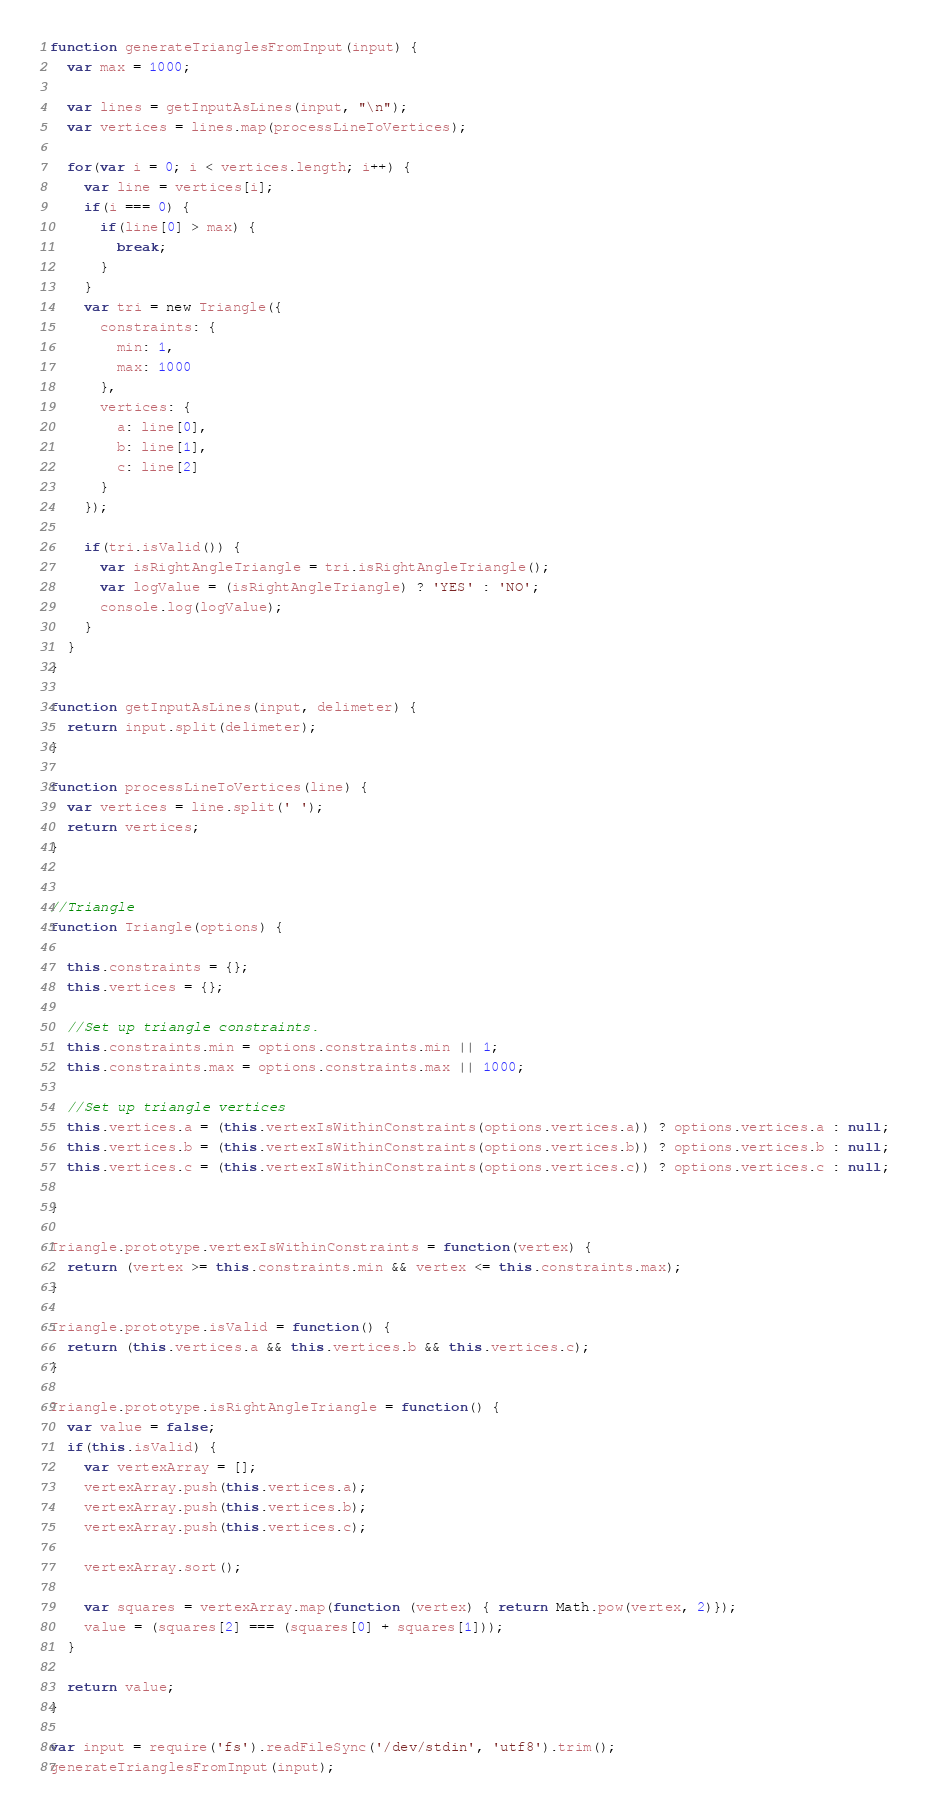Convert code to text. <code><loc_0><loc_0><loc_500><loc_500><_JavaScript_>function generateTrianglesFromInput(input) {
  var max = 1000;

  var lines = getInputAsLines(input, "\n");
  var vertices = lines.map(processLineToVertices);

  for(var i = 0; i < vertices.length; i++) {
    var line = vertices[i];
    if(i === 0) {
      if(line[0] > max) {
        break;
      }
    }
    var tri = new Triangle({
      constraints: {
        min: 1,
        max: 1000
      },
      vertices: {
        a: line[0],
        b: line[1],
        c: line[2]
      }
    });

    if(tri.isValid()) {
      var isRightAngleTriangle = tri.isRightAngleTriangle();
      var logValue = (isRightAngleTriangle) ? 'YES' : 'NO';
      console.log(logValue);
    }
  }
}

function getInputAsLines(input, delimeter) {
  return input.split(delimeter);
}

function processLineToVertices(line) {
  var vertices = line.split(' ');
  return vertices;
}


//Triangle
function Triangle(options) {

  this.constraints = {};
  this.vertices = {};

  //Set up triangle constraints.
  this.constraints.min = options.constraints.min || 1;
  this.constraints.max = options.constraints.max || 1000;

  //Set up triangle vertices
  this.vertices.a = (this.vertexIsWithinConstraints(options.vertices.a)) ? options.vertices.a : null;
  this.vertices.b = (this.vertexIsWithinConstraints(options.vertices.b)) ? options.vertices.b : null;
  this.vertices.c = (this.vertexIsWithinConstraints(options.vertices.c)) ? options.vertices.c : null;

}

Triangle.prototype.vertexIsWithinConstraints = function(vertex) {
  return (vertex >= this.constraints.min && vertex <= this.constraints.max);
}

Triangle.prototype.isValid = function() {
  return (this.vertices.a && this.vertices.b && this.vertices.c);
}

Triangle.prototype.isRightAngleTriangle = function() {
  var value = false;
  if(this.isValid) {
    var vertexArray = [];
    vertexArray.push(this.vertices.a);
    vertexArray.push(this.vertices.b);
    vertexArray.push(this.vertices.c);

    vertexArray.sort();

    var squares = vertexArray.map(function (vertex) { return Math.pow(vertex, 2)});
    value = (squares[2] === (squares[0] + squares[1]));
  }

  return value;
}

var input = require('fs').readFileSync('/dev/stdin', 'utf8').trim();
generateTrianglesFromInput(input);</code> 